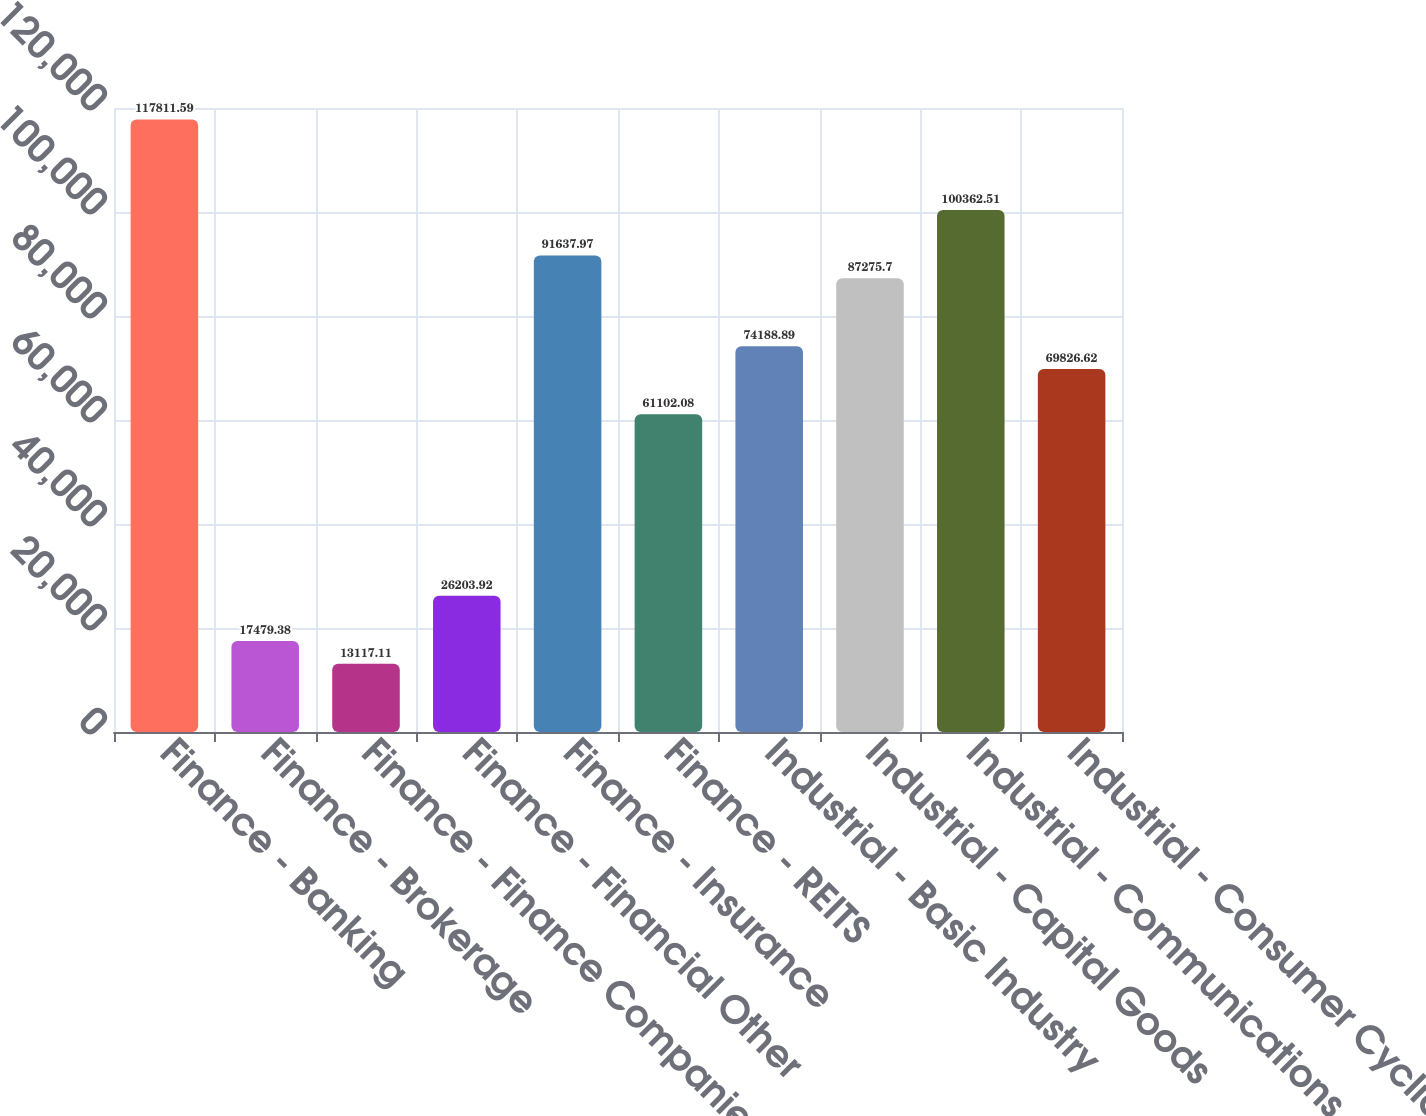Convert chart to OTSL. <chart><loc_0><loc_0><loc_500><loc_500><bar_chart><fcel>Finance - Banking<fcel>Finance - Brokerage<fcel>Finance - Finance Companies<fcel>Finance - Financial Other<fcel>Finance - Insurance<fcel>Finance - REITS<fcel>Industrial - Basic Industry<fcel>Industrial - Capital Goods<fcel>Industrial - Communications<fcel>Industrial - Consumer Cyclical<nl><fcel>117812<fcel>17479.4<fcel>13117.1<fcel>26203.9<fcel>91638<fcel>61102.1<fcel>74188.9<fcel>87275.7<fcel>100363<fcel>69826.6<nl></chart> 